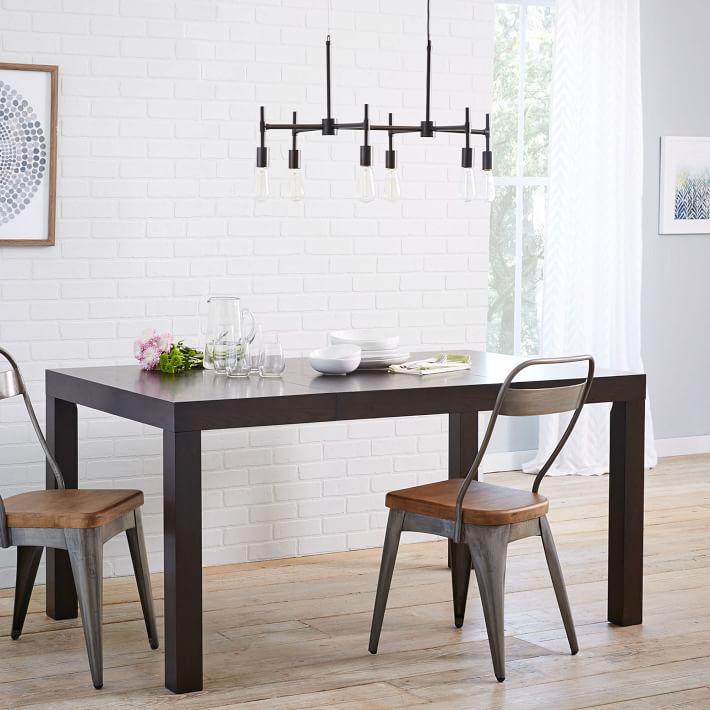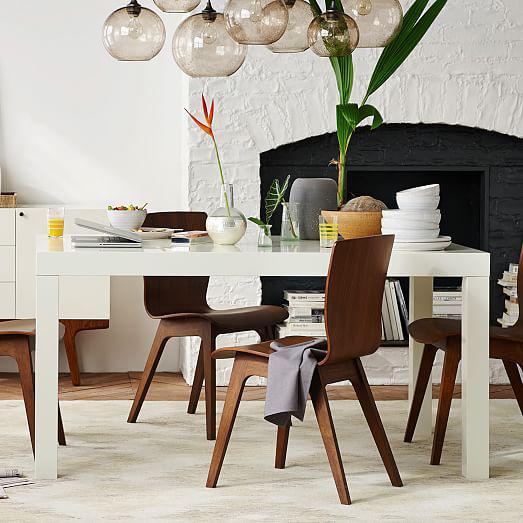The first image is the image on the left, the second image is the image on the right. Analyze the images presented: Is the assertion "There are three windows on the left wall in the image on the left." valid? Answer yes or no. No. 